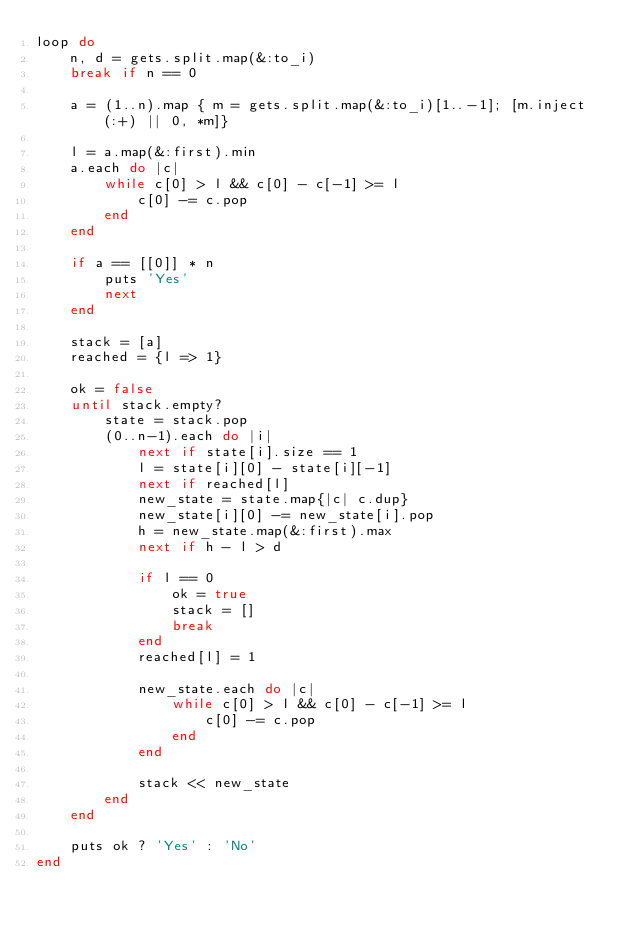Convert code to text. <code><loc_0><loc_0><loc_500><loc_500><_Ruby_>loop do
    n, d = gets.split.map(&:to_i)
    break if n == 0

    a = (1..n).map { m = gets.split.map(&:to_i)[1..-1]; [m.inject(:+) || 0, *m]}

    l = a.map(&:first).min
    a.each do |c|
        while c[0] > l && c[0] - c[-1] >= l
            c[0] -= c.pop
        end
    end

    if a == [[0]] * n
        puts 'Yes'
        next
    end

    stack = [a]
    reached = {l => 1}

    ok = false
    until stack.empty?
        state = stack.pop
        (0..n-1).each do |i|
            next if state[i].size == 1
            l = state[i][0] - state[i][-1]
            next if reached[l]
            new_state = state.map{|c| c.dup}
            new_state[i][0] -= new_state[i].pop
            h = new_state.map(&:first).max 
            next if h - l > d

            if l == 0
                ok = true
                stack = []
                break
            end 
            reached[l] = 1

            new_state.each do |c|
                while c[0] > l && c[0] - c[-1] >= l
                    c[0] -= c.pop
                end
            end

            stack << new_state
        end
    end

    puts ok ? 'Yes' : 'No'
end</code> 